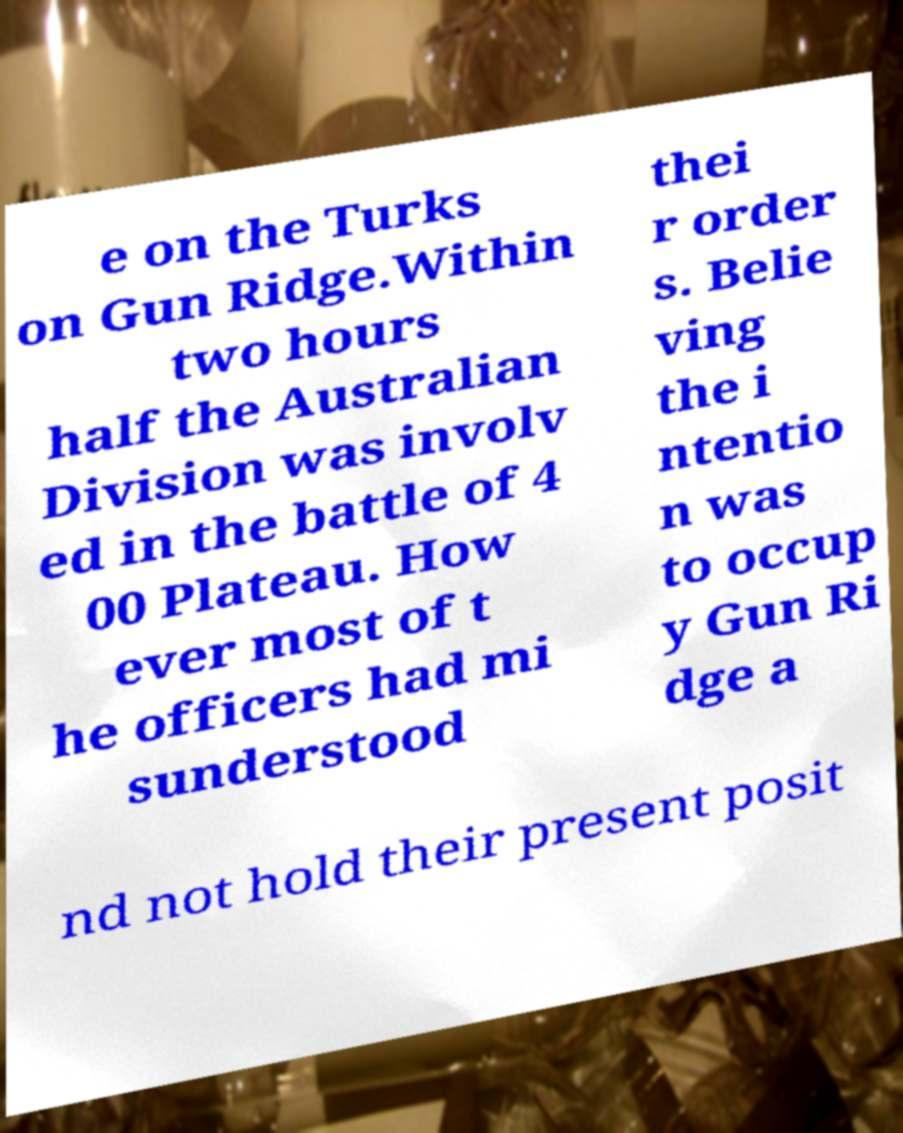Can you read and provide the text displayed in the image?This photo seems to have some interesting text. Can you extract and type it out for me? e on the Turks on Gun Ridge.Within two hours half the Australian Division was involv ed in the battle of 4 00 Plateau. How ever most of t he officers had mi sunderstood thei r order s. Belie ving the i ntentio n was to occup y Gun Ri dge a nd not hold their present posit 